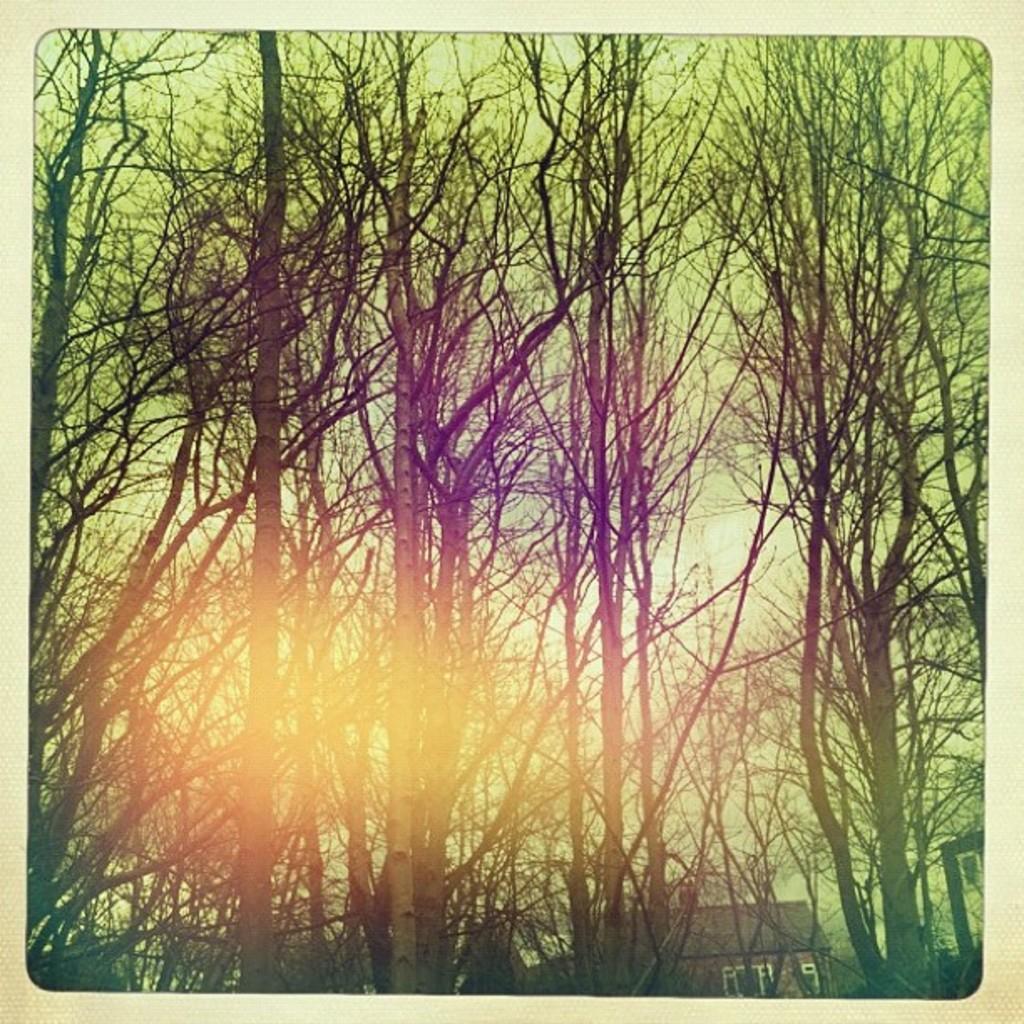How would you summarize this image in a sentence or two? In this picture I can see there is a building, trees and the sky is clear. 